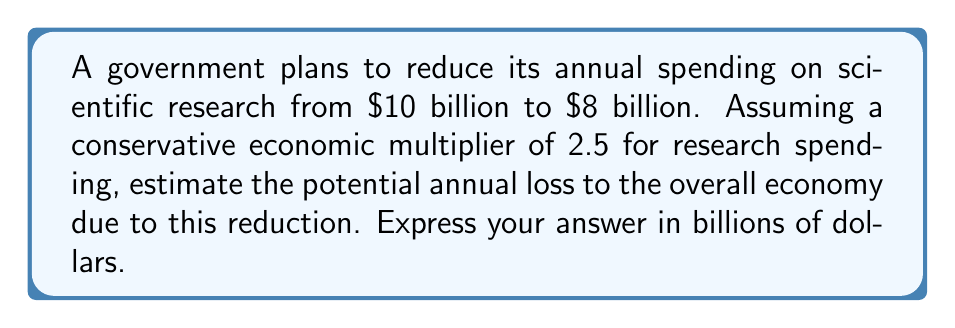Teach me how to tackle this problem. To solve this problem, we'll follow these steps:

1) Calculate the reduction in government spending:
   $10 billion - $8 billion = $2 billion

2) Apply the economic multiplier:
   The economic multiplier represents the total economic impact of each dollar spent. In this case, each dollar spent on research generates $2.50 in overall economic activity.

   We can represent this mathematically as:
   $$\text{Total Economic Impact} = \text{Initial Spending} \times \text{Multiplier}$$

3) Calculate the total economic impact of the spending reduction:
   $$\text{Economic Impact} = $2 \text{ billion} \times 2.5 = $5 \text{ billion}$$

This means that a $2 billion reduction in government research spending could potentially lead to a $5 billion reduction in overall economic activity.

Note: As a skeptical economist, you might question whether this multiplier is accurate or if it overstates the impact of government spending. However, for the purposes of this calculation, we'll use the given multiplier.
Answer: $5 billion 